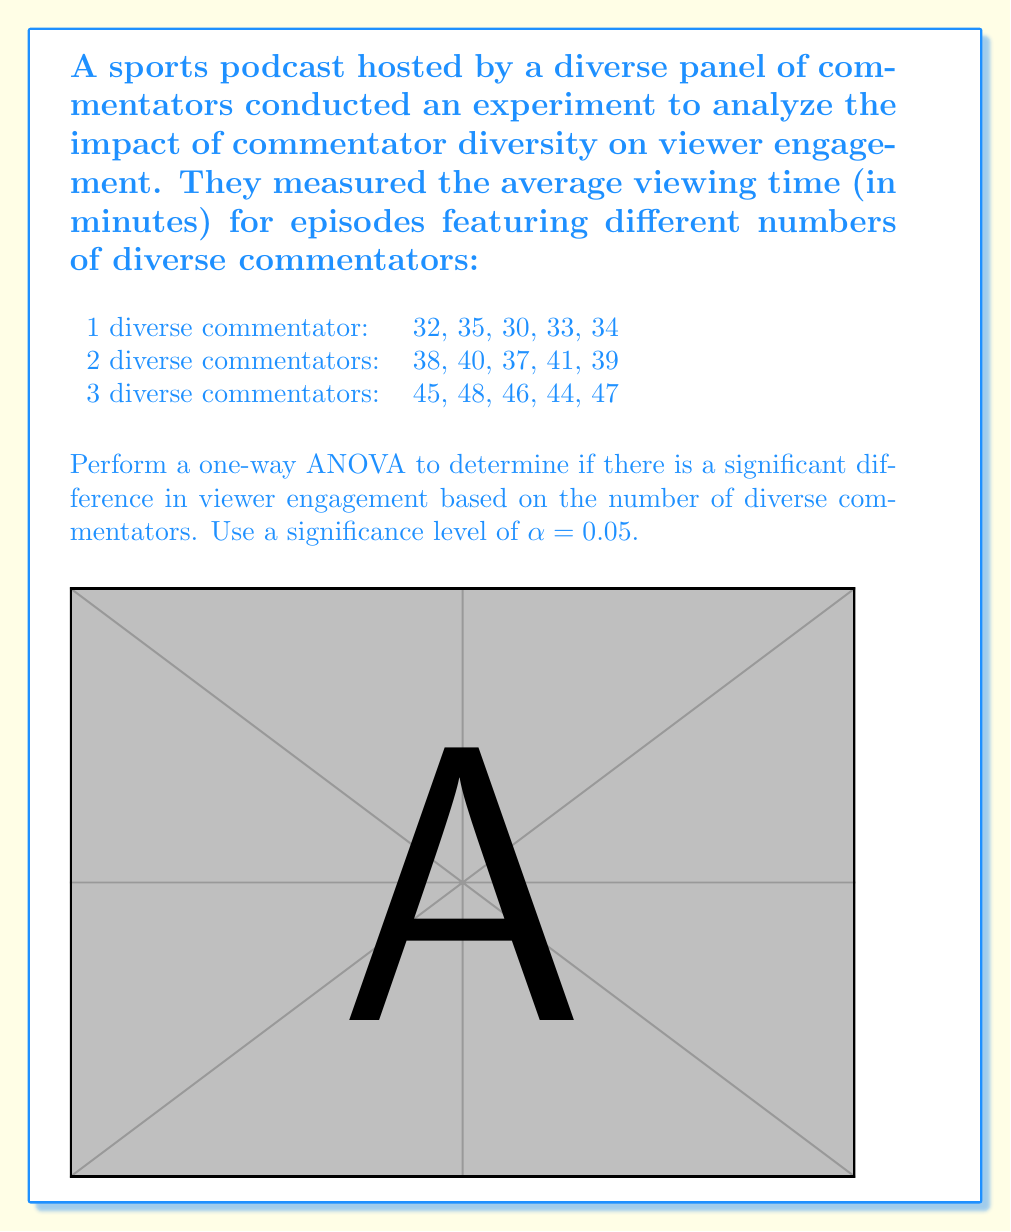Can you answer this question? Let's perform a one-way ANOVA step-by-step:

1. Calculate the means for each group:
   Group 1: $\bar{X}_1 = \frac{32 + 35 + 30 + 33 + 34}{5} = 32.8$
   Group 2: $\bar{X}_2 = \frac{38 + 40 + 37 + 41 + 39}{5} = 39$
   Group 3: $\bar{X}_3 = \frac{45 + 48 + 46 + 44 + 47}{5} = 46$

2. Calculate the grand mean:
   $\bar{X} = \frac{32.8 + 39 + 46}{3} = 39.27$

3. Calculate the Sum of Squares Between (SSB):
   $SSB = 5[(32.8 - 39.27)^2 + (39 - 39.27)^2 + (46 - 39.27)^2] = 433.63$

4. Calculate the Sum of Squares Within (SSW):
   $SSW = [(32-32.8)^2 + (35-32.8)^2 + ... + (47-46)^2] = 66.8$

5. Calculate the Sum of Squares Total (SST):
   $SST = SSB + SSW = 433.63 + 66.8 = 500.43$

6. Calculate degrees of freedom:
   $df_{between} = k - 1 = 3 - 1 = 2$
   $df_{within} = N - k = 15 - 3 = 12$
   $df_{total} = N - 1 = 15 - 1 = 14$

7. Calculate Mean Square Between (MSB) and Mean Square Within (MSW):
   $MSB = \frac{SSB}{df_{between}} = \frac{433.63}{2} = 216.815$
   $MSW = \frac{SSW}{df_{within}} = \frac{66.8}{12} = 5.567$

8. Calculate the F-statistic:
   $F = \frac{MSB}{MSW} = \frac{216.815}{5.567} = 38.95$

9. Find the critical F-value:
   $F_{crit} = F_{0.05, 2, 12} = 3.89$ (from F-distribution table)

10. Compare F-statistic to F-critical:
    Since $38.95 > 3.89$, we reject the null hypothesis.

11. Calculate p-value:
    $p \approx 0.000005 < 0.05$
Answer: $F(2,12) = 38.95, p < 0.05$. Significant difference exists. 